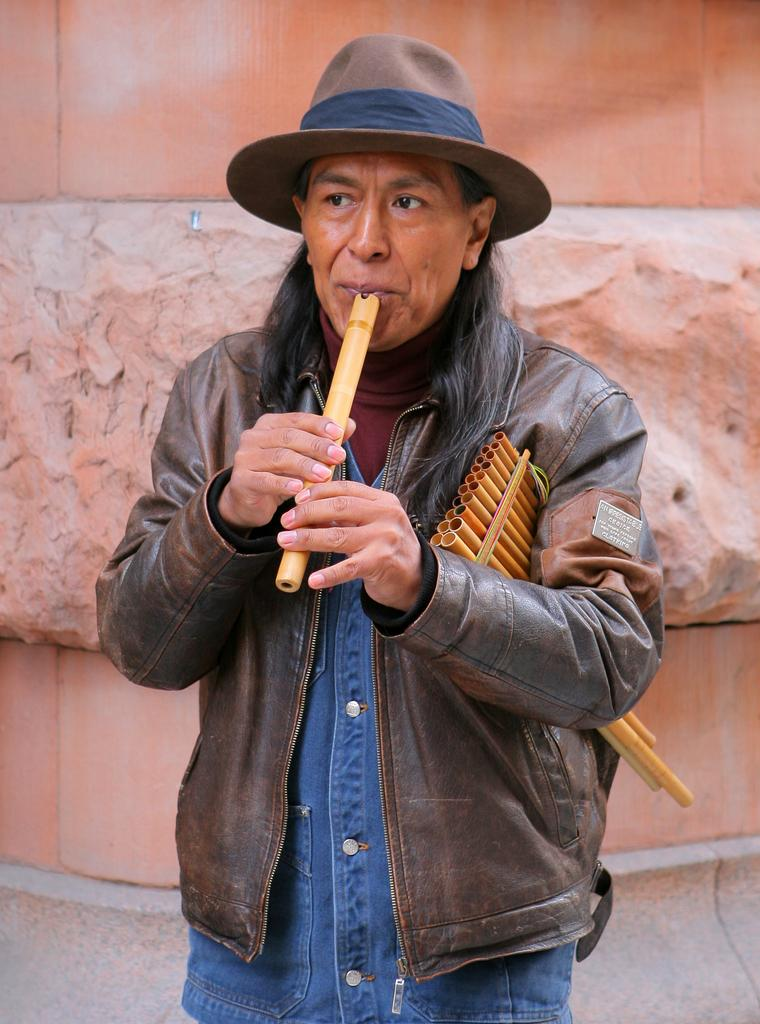What is the man in the picture doing? The man is playing a flute. How is the man holding the flute? The man is holding the flute with both hands. What is the man wearing on his head? The man is wearing a cap. How much credit does the man have in the image? There is no mention of credit in the image, as it features a man playing a flute. What force is being applied to the flute by the man? The question cannot be answered definitively, as the force applied to the flute is not visible in the image. 